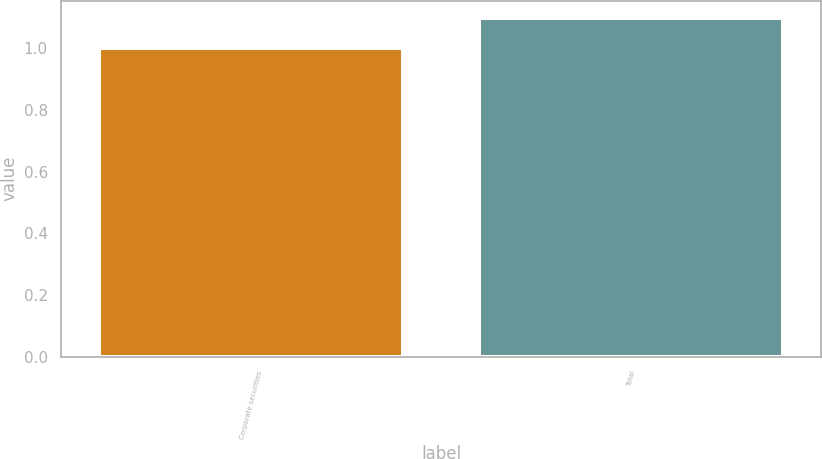Convert chart to OTSL. <chart><loc_0><loc_0><loc_500><loc_500><bar_chart><fcel>Corporate securities<fcel>Total<nl><fcel>1<fcel>1.1<nl></chart> 